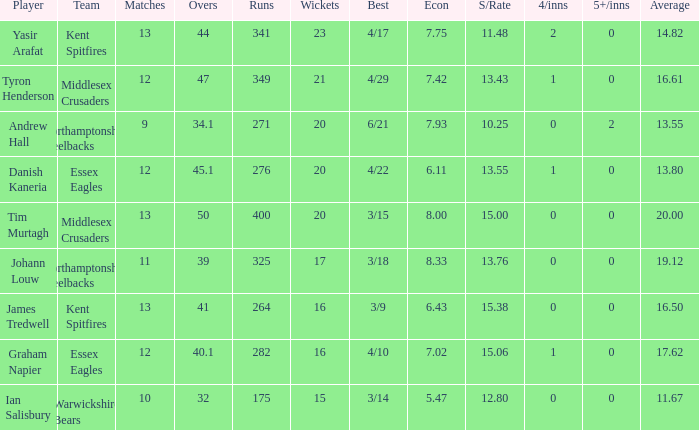In which matches does the 17th wicket take place? 11.0. 